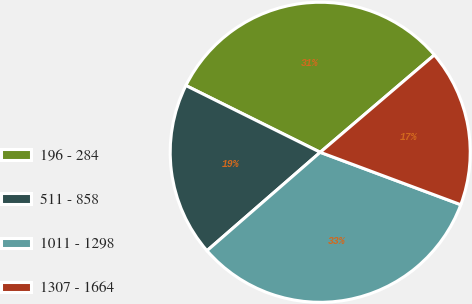<chart> <loc_0><loc_0><loc_500><loc_500><pie_chart><fcel>196 - 284<fcel>511 - 858<fcel>1011 - 1298<fcel>1307 - 1664<nl><fcel>31.42%<fcel>18.73%<fcel>32.93%<fcel>16.92%<nl></chart> 